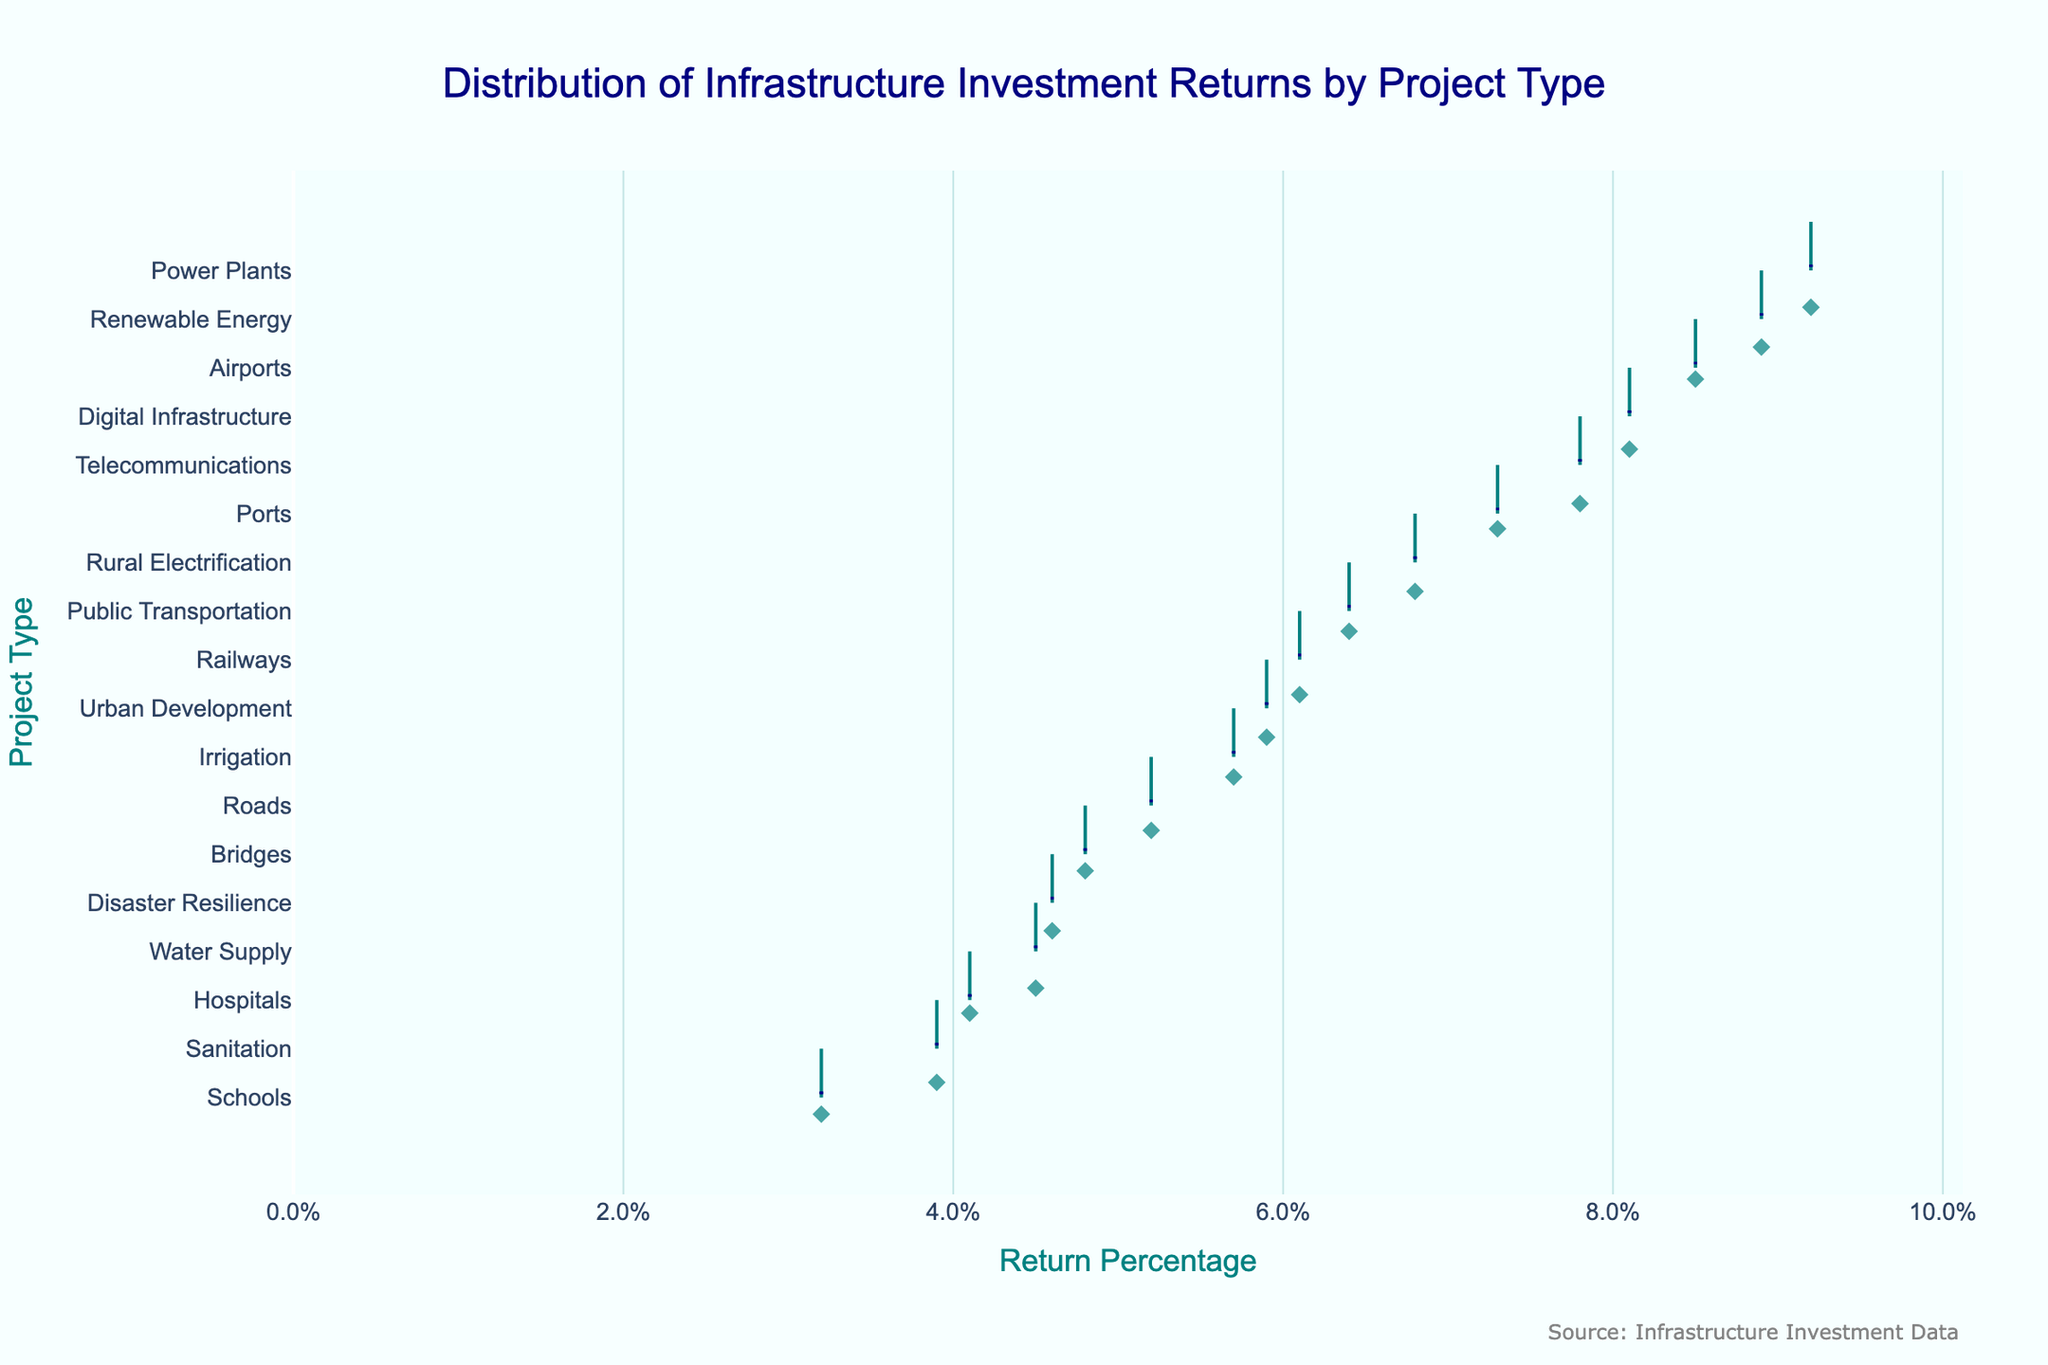What is the title of the plot? The title of the plot is displayed at the top and reads "Distribution of Infrastructure Investment Returns by Project Type."
Answer: Distribution of Infrastructure Investment Returns by Project Type Which project type has the highest return percentage? By looking at the x-axis values and the aligned data points, "Power Plants" have the highest return percentage.
Answer: Power Plants How many project types have a return percentage higher than 7%? Checking the right side of the x-axis above the 7% mark, the project types are "Ports," "Airports," "Telecommunications," "Renewable Energy," and "Digital Infrastructure." This counts to five project types.
Answer: 5 What is the range of return percentages shown on the x-axis? The x-axis starts from 0% to approximately 10% based on the plotted data points and the axis range setup.
Answer: 0% to approximately 10% Which project type is closest to the median percentage of returns? The median can be estimated by finding the middle project type in terms of returns. "Public Transportation" at 6.4% appears to be closest to the median as it is near the center of the sorted list of return percentages.
Answer: Public Transportation Which two project types have the closest return percentages, and what are those values? Looking closely at adjacent points on the y-axis, "Bridges" and "Roads" have return percentages of 4.8% and 5.2% respectively, which are very close.
Answer: Bridges (4.8%) and Roads (5.2%) What is the return percentage difference between the project type with the highest returns and the one with the lowest returns? The highest return is Power Plants at 9.2%, and the lowest is Schools at 3.2%. The difference would be 9.2% - 3.2% = 6.0%.
Answer: 6.0% How does the return percentage of "Urban Development" compare to that of "Rural Electrification"? "Urban Development" has a return of 5.9%, while "Rural Electrification" has a return of 6.8%. "Rural Electrification" has a higher return.
Answer: Rural Electrification has a higher return What color is used to represent the mean line in the violin plot? By looking at the plot, the mean line is represented in dark blue.
Answer: Dark blue Which project type shows significant outliers in their return percentage? By observing the box plots within the violins, "Telecommunications" shows significant outliers because of the scattered data points.
Answer: Telecommunications 